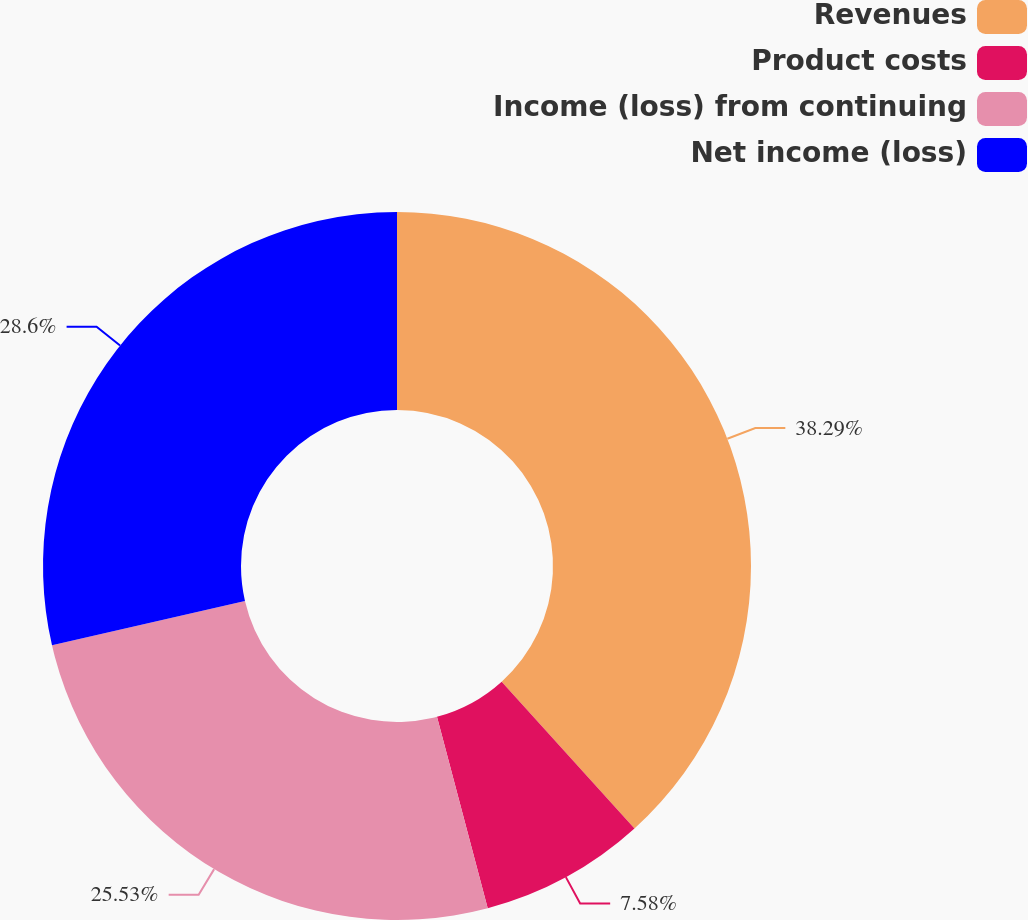<chart> <loc_0><loc_0><loc_500><loc_500><pie_chart><fcel>Revenues<fcel>Product costs<fcel>Income (loss) from continuing<fcel>Net income (loss)<nl><fcel>38.3%<fcel>7.58%<fcel>25.53%<fcel>28.6%<nl></chart> 